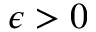Convert formula to latex. <formula><loc_0><loc_0><loc_500><loc_500>\epsilon > 0</formula> 